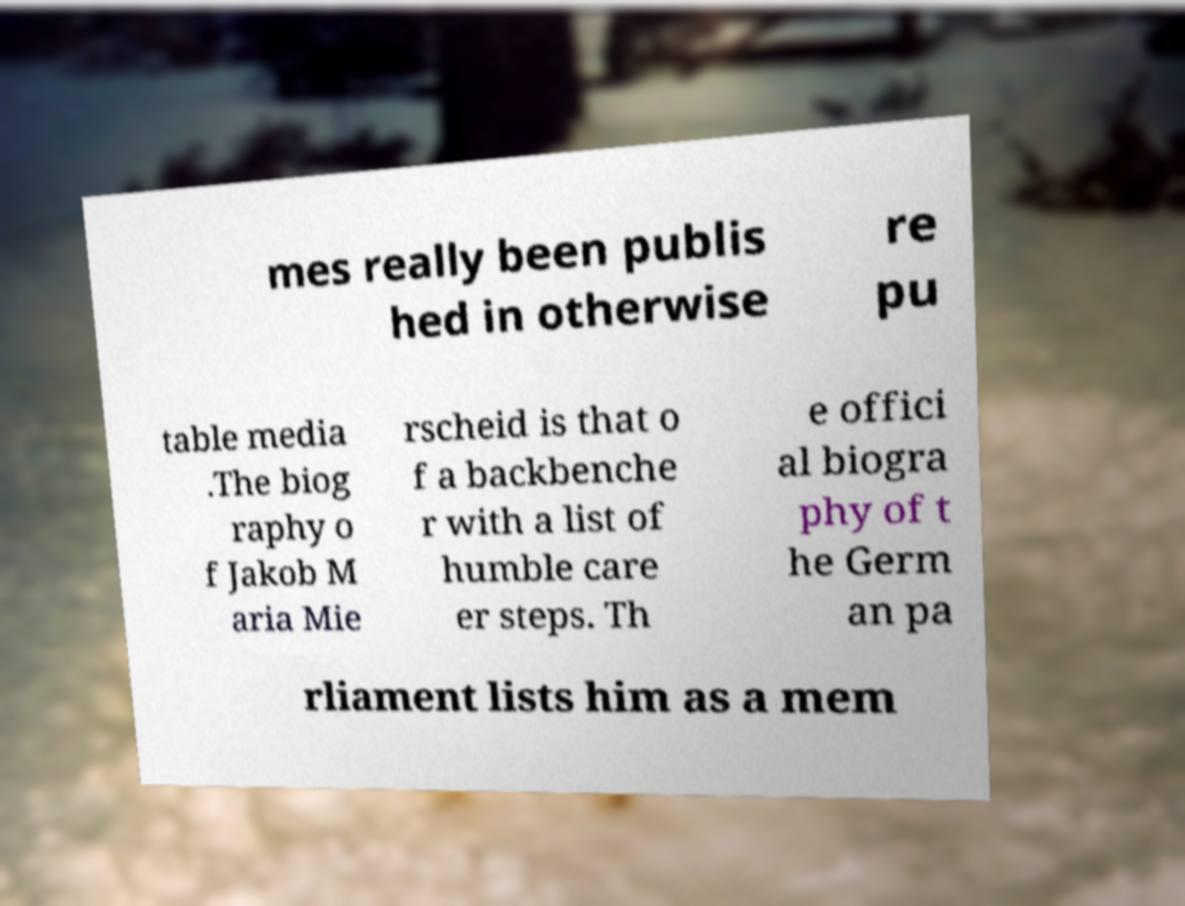Can you read and provide the text displayed in the image?This photo seems to have some interesting text. Can you extract and type it out for me? mes really been publis hed in otherwise re pu table media .The biog raphy o f Jakob M aria Mie rscheid is that o f a backbenche r with a list of humble care er steps. Th e offici al biogra phy of t he Germ an pa rliament lists him as a mem 